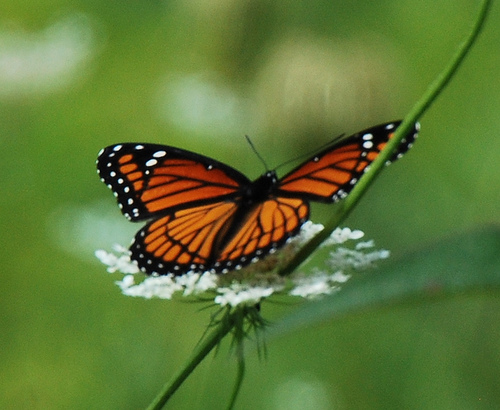<image>
Can you confirm if the butterfly is above the flower? Yes. The butterfly is positioned above the flower in the vertical space, higher up in the scene. 